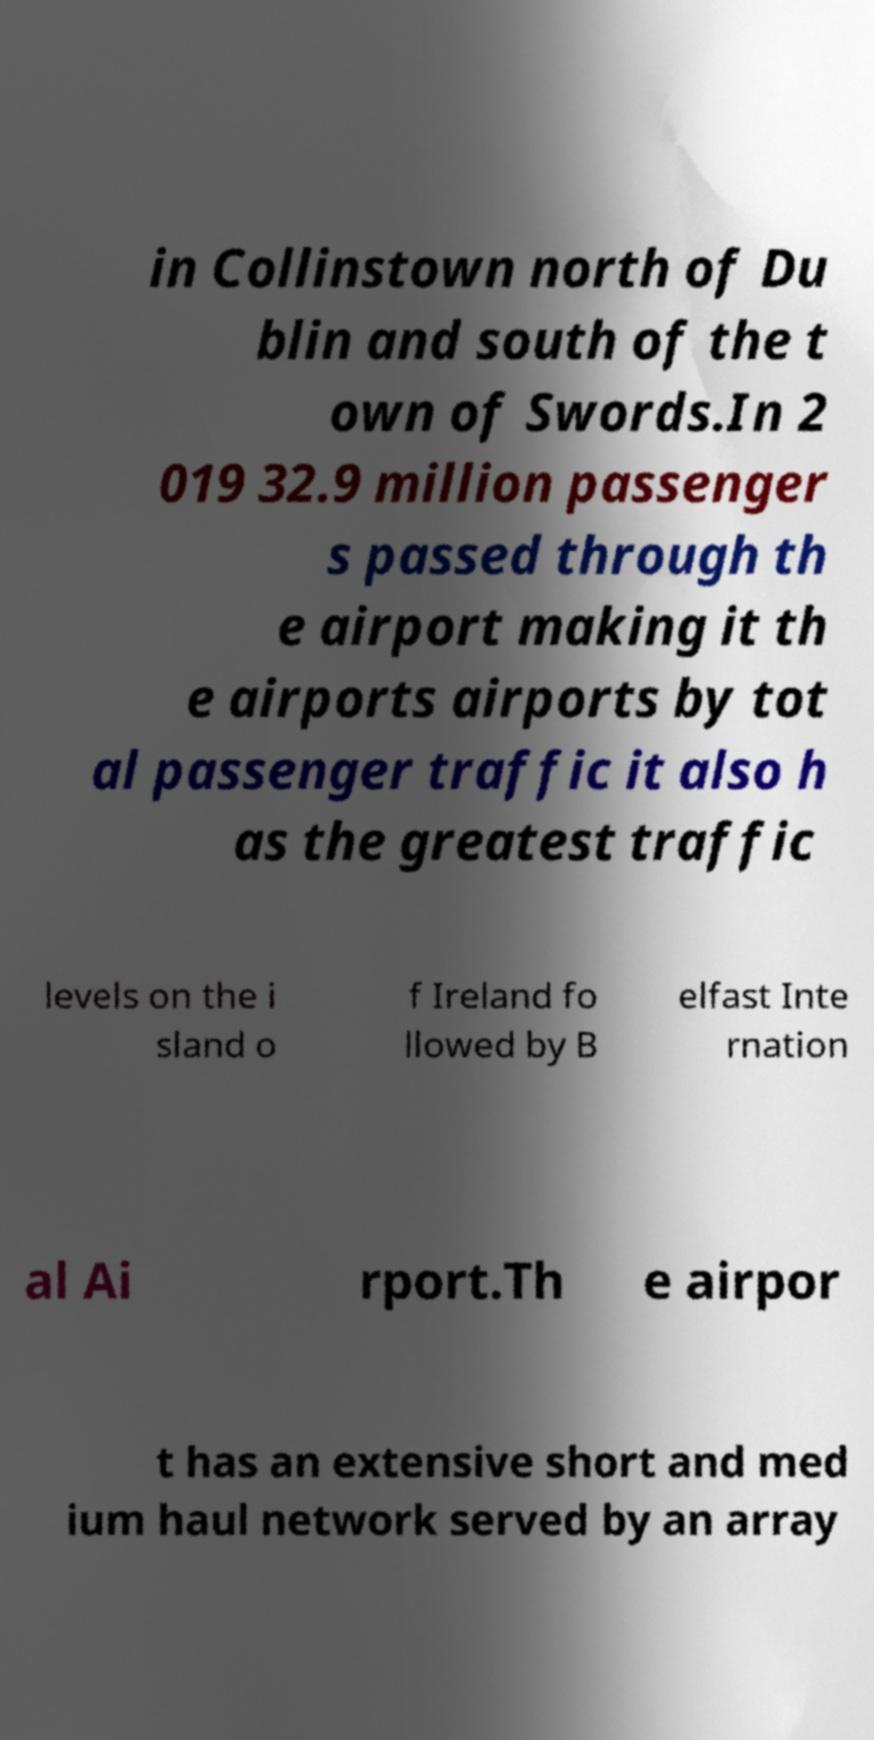Please read and relay the text visible in this image. What does it say? in Collinstown north of Du blin and south of the t own of Swords.In 2 019 32.9 million passenger s passed through th e airport making it th e airports airports by tot al passenger traffic it also h as the greatest traffic levels on the i sland o f Ireland fo llowed by B elfast Inte rnation al Ai rport.Th e airpor t has an extensive short and med ium haul network served by an array 